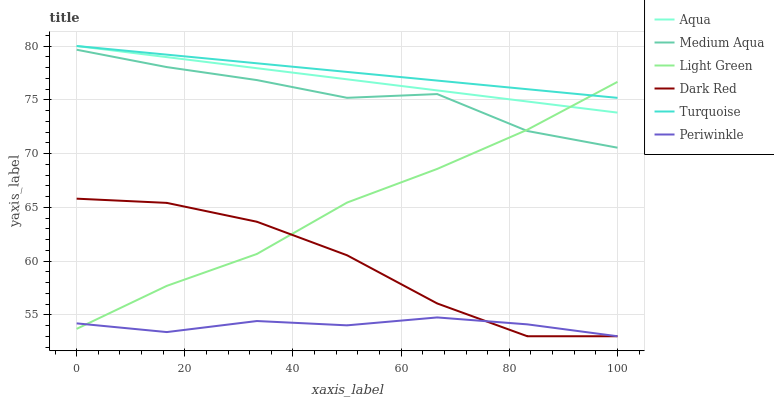Does Periwinkle have the minimum area under the curve?
Answer yes or no. Yes. Does Turquoise have the maximum area under the curve?
Answer yes or no. Yes. Does Dark Red have the minimum area under the curve?
Answer yes or no. No. Does Dark Red have the maximum area under the curve?
Answer yes or no. No. Is Turquoise the smoothest?
Answer yes or no. Yes. Is Dark Red the roughest?
Answer yes or no. Yes. Is Aqua the smoothest?
Answer yes or no. No. Is Aqua the roughest?
Answer yes or no. No. Does Dark Red have the lowest value?
Answer yes or no. Yes. Does Aqua have the lowest value?
Answer yes or no. No. Does Aqua have the highest value?
Answer yes or no. Yes. Does Dark Red have the highest value?
Answer yes or no. No. Is Dark Red less than Turquoise?
Answer yes or no. Yes. Is Medium Aqua greater than Dark Red?
Answer yes or no. Yes. Does Light Green intersect Turquoise?
Answer yes or no. Yes. Is Light Green less than Turquoise?
Answer yes or no. No. Is Light Green greater than Turquoise?
Answer yes or no. No. Does Dark Red intersect Turquoise?
Answer yes or no. No. 